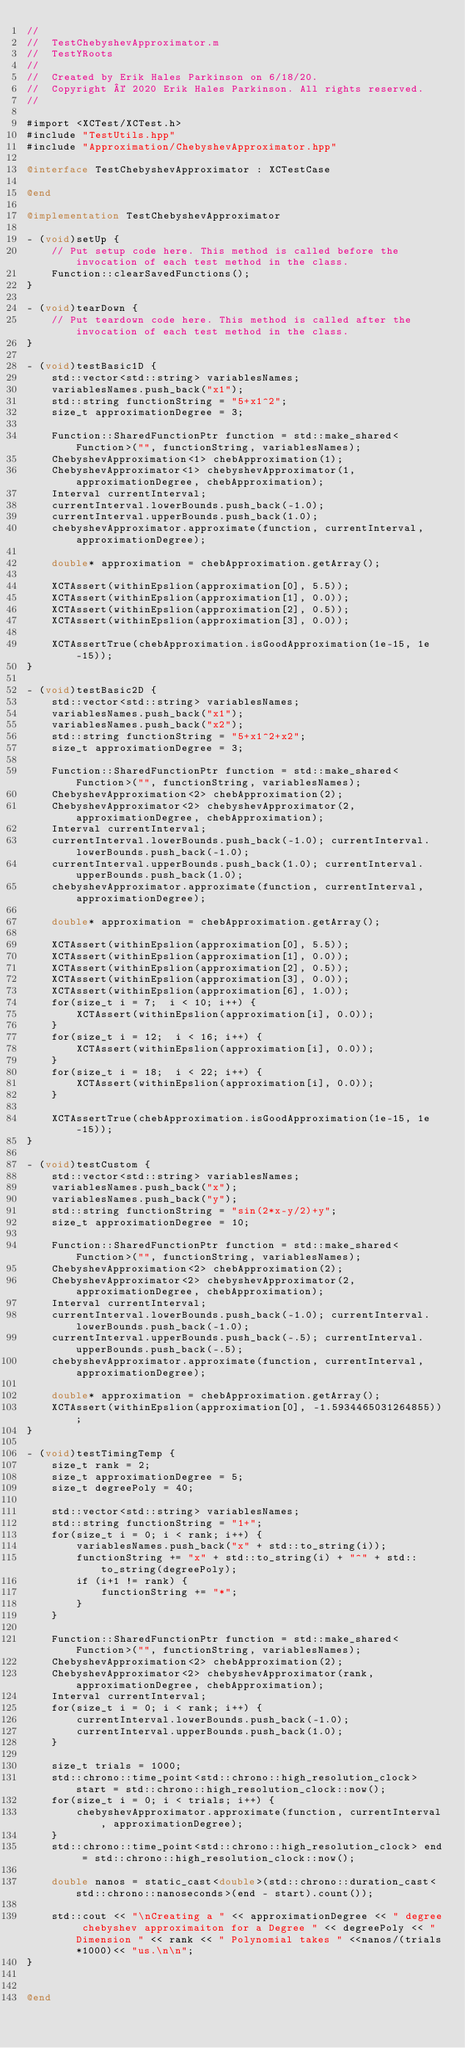Convert code to text. <code><loc_0><loc_0><loc_500><loc_500><_ObjectiveC_>//
//  TestChebyshevApproximator.m
//  TestYRoots
//
//  Created by Erik Hales Parkinson on 6/18/20.
//  Copyright © 2020 Erik Hales Parkinson. All rights reserved.
//

#import <XCTest/XCTest.h>
#include "TestUtils.hpp"
#include "Approximation/ChebyshevApproximator.hpp"

@interface TestChebyshevApproximator : XCTestCase

@end

@implementation TestChebyshevApproximator

- (void)setUp {
    // Put setup code here. This method is called before the invocation of each test method in the class.
    Function::clearSavedFunctions();
}

- (void)tearDown {
    // Put teardown code here. This method is called after the invocation of each test method in the class.
}

- (void)testBasic1D {
    std::vector<std::string> variablesNames;
    variablesNames.push_back("x1");
    std::string functionString = "5+x1^2";
    size_t approximationDegree = 3;
    
    Function::SharedFunctionPtr function = std::make_shared<Function>("", functionString, variablesNames);
    ChebyshevApproximation<1> chebApproximation(1);
    ChebyshevApproximator<1> chebyshevApproximator(1, approximationDegree, chebApproximation);
    Interval currentInterval;
    currentInterval.lowerBounds.push_back(-1.0);
    currentInterval.upperBounds.push_back(1.0);
    chebyshevApproximator.approximate(function, currentInterval, approximationDegree);

    double* approximation = chebApproximation.getArray();
    
    XCTAssert(withinEpslion(approximation[0], 5.5));
    XCTAssert(withinEpslion(approximation[1], 0.0));
    XCTAssert(withinEpslion(approximation[2], 0.5));
    XCTAssert(withinEpslion(approximation[3], 0.0));
    
    XCTAssertTrue(chebApproximation.isGoodApproximation(1e-15, 1e-15));
}

- (void)testBasic2D {
    std::vector<std::string> variablesNames;
    variablesNames.push_back("x1");
    variablesNames.push_back("x2");
    std::string functionString = "5+x1^2+x2";
    size_t approximationDegree = 3;
    
    Function::SharedFunctionPtr function = std::make_shared<Function>("", functionString, variablesNames);
    ChebyshevApproximation<2> chebApproximation(2);
    ChebyshevApproximator<2> chebyshevApproximator(2, approximationDegree, chebApproximation);
    Interval currentInterval;
    currentInterval.lowerBounds.push_back(-1.0); currentInterval.lowerBounds.push_back(-1.0);
    currentInterval.upperBounds.push_back(1.0); currentInterval.upperBounds.push_back(1.0);
    chebyshevApproximator.approximate(function, currentInterval, approximationDegree);

    double* approximation = chebApproximation.getArray();
        
    XCTAssert(withinEpslion(approximation[0], 5.5));
    XCTAssert(withinEpslion(approximation[1], 0.0));
    XCTAssert(withinEpslion(approximation[2], 0.5));
    XCTAssert(withinEpslion(approximation[3], 0.0));
    XCTAssert(withinEpslion(approximation[6], 1.0));
    for(size_t i = 7;  i < 10; i++) {
        XCTAssert(withinEpslion(approximation[i], 0.0));
    }
    for(size_t i = 12;  i < 16; i++) {
        XCTAssert(withinEpslion(approximation[i], 0.0));
    }
    for(size_t i = 18;  i < 22; i++) {
        XCTAssert(withinEpslion(approximation[i], 0.0));
    }
    
    XCTAssertTrue(chebApproximation.isGoodApproximation(1e-15, 1e-15));
}

- (void)testCustom {
    std::vector<std::string> variablesNames;
    variablesNames.push_back("x");
    variablesNames.push_back("y");
    std::string functionString = "sin(2*x-y/2)+y";
    size_t approximationDegree = 10;
    
    Function::SharedFunctionPtr function = std::make_shared<Function>("", functionString, variablesNames);
    ChebyshevApproximation<2> chebApproximation(2);
    ChebyshevApproximator<2> chebyshevApproximator(2, approximationDegree, chebApproximation);
    Interval currentInterval;
    currentInterval.lowerBounds.push_back(-1.0); currentInterval.lowerBounds.push_back(-1.0);
    currentInterval.upperBounds.push_back(-.5); currentInterval.upperBounds.push_back(-.5);
    chebyshevApproximator.approximate(function, currentInterval, approximationDegree);

    double* approximation = chebApproximation.getArray();
    XCTAssert(withinEpslion(approximation[0], -1.5934465031264855));
}
    
- (void)testTimingTemp {
    size_t rank = 2;
    size_t approximationDegree = 5;    
    size_t degreePoly = 40;

    std::vector<std::string> variablesNames;
    std::string functionString = "1+";
    for(size_t i = 0; i < rank; i++) {
        variablesNames.push_back("x" + std::to_string(i));
        functionString += "x" + std::to_string(i) + "^" + std::to_string(degreePoly);
        if (i+1 != rank) {
            functionString += "*";
        }
    }

    Function::SharedFunctionPtr function = std::make_shared<Function>("", functionString, variablesNames);
    ChebyshevApproximation<2> chebApproximation(2);
    ChebyshevApproximator<2> chebyshevApproximator(rank, approximationDegree, chebApproximation);
    Interval currentInterval;
    for(size_t i = 0; i < rank; i++) {
        currentInterval.lowerBounds.push_back(-1.0);
        currentInterval.upperBounds.push_back(1.0);
    }

    size_t trials = 1000;
    std::chrono::time_point<std::chrono::high_resolution_clock> start = std::chrono::high_resolution_clock::now();
    for(size_t i = 0; i < trials; i++) {
        chebyshevApproximator.approximate(function, currentInterval, approximationDegree);
    }
    std::chrono::time_point<std::chrono::high_resolution_clock> end = std::chrono::high_resolution_clock::now();

    double nanos = static_cast<double>(std::chrono::duration_cast<std::chrono::nanoseconds>(end - start).count());
    
    std::cout << "\nCreating a " << approximationDegree << " degree chebyshev approximaiton for a Degree " << degreePoly << " Dimension " << rank << " Polynomial takes " <<nanos/(trials*1000)<< "us.\n\n";
}


@end
</code> 